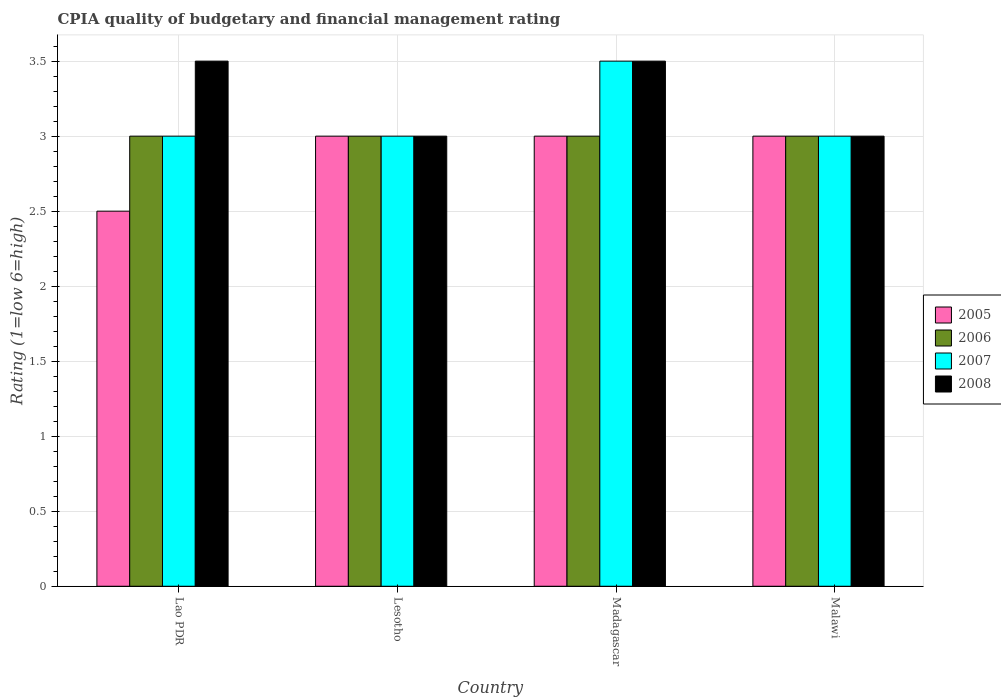How many different coloured bars are there?
Ensure brevity in your answer.  4. How many bars are there on the 2nd tick from the left?
Provide a short and direct response. 4. What is the label of the 1st group of bars from the left?
Provide a succinct answer. Lao PDR. In how many cases, is the number of bars for a given country not equal to the number of legend labels?
Provide a short and direct response. 0. Across all countries, what is the minimum CPIA rating in 2006?
Provide a short and direct response. 3. In which country was the CPIA rating in 2005 maximum?
Your response must be concise. Lesotho. In which country was the CPIA rating in 2005 minimum?
Make the answer very short. Lao PDR. What is the total CPIA rating in 2007 in the graph?
Offer a terse response. 12.5. What is the difference between the CPIA rating in 2005 in Lao PDR and the CPIA rating in 2006 in Lesotho?
Offer a terse response. -0.5. In how many countries, is the CPIA rating in 2007 greater than 3?
Your answer should be very brief. 1. What is the ratio of the CPIA rating in 2008 in Madagascar to that in Malawi?
Make the answer very short. 1.17. What is the difference between the highest and the second highest CPIA rating in 2007?
Offer a very short reply. -0.5. In how many countries, is the CPIA rating in 2005 greater than the average CPIA rating in 2005 taken over all countries?
Your answer should be compact. 3. Is the sum of the CPIA rating in 2005 in Lao PDR and Madagascar greater than the maximum CPIA rating in 2006 across all countries?
Your answer should be compact. Yes. What does the 1st bar from the left in Lao PDR represents?
Your answer should be very brief. 2005. What does the 4th bar from the right in Lesotho represents?
Keep it short and to the point. 2005. Is it the case that in every country, the sum of the CPIA rating in 2006 and CPIA rating in 2007 is greater than the CPIA rating in 2008?
Give a very brief answer. Yes. How many countries are there in the graph?
Your answer should be compact. 4. Are the values on the major ticks of Y-axis written in scientific E-notation?
Ensure brevity in your answer.  No. Does the graph contain any zero values?
Make the answer very short. No. Where does the legend appear in the graph?
Your answer should be very brief. Center right. How are the legend labels stacked?
Make the answer very short. Vertical. What is the title of the graph?
Your response must be concise. CPIA quality of budgetary and financial management rating. Does "1985" appear as one of the legend labels in the graph?
Offer a terse response. No. What is the Rating (1=low 6=high) of 2005 in Lao PDR?
Offer a very short reply. 2.5. What is the Rating (1=low 6=high) in 2006 in Lao PDR?
Your answer should be compact. 3. What is the Rating (1=low 6=high) in 2007 in Lao PDR?
Give a very brief answer. 3. What is the Rating (1=low 6=high) in 2005 in Lesotho?
Offer a very short reply. 3. What is the Rating (1=low 6=high) in 2006 in Lesotho?
Your answer should be compact. 3. What is the Rating (1=low 6=high) of 2008 in Lesotho?
Your response must be concise. 3. What is the Rating (1=low 6=high) in 2005 in Madagascar?
Provide a succinct answer. 3. What is the Rating (1=low 6=high) in 2006 in Madagascar?
Keep it short and to the point. 3. What is the Rating (1=low 6=high) of 2005 in Malawi?
Your response must be concise. 3. What is the Rating (1=low 6=high) in 2008 in Malawi?
Your response must be concise. 3. Across all countries, what is the maximum Rating (1=low 6=high) in 2005?
Provide a short and direct response. 3. Across all countries, what is the maximum Rating (1=low 6=high) of 2006?
Provide a succinct answer. 3. Across all countries, what is the maximum Rating (1=low 6=high) in 2007?
Your answer should be compact. 3.5. Across all countries, what is the maximum Rating (1=low 6=high) in 2008?
Provide a succinct answer. 3.5. Across all countries, what is the minimum Rating (1=low 6=high) in 2005?
Offer a very short reply. 2.5. Across all countries, what is the minimum Rating (1=low 6=high) in 2007?
Your answer should be very brief. 3. What is the total Rating (1=low 6=high) in 2005 in the graph?
Ensure brevity in your answer.  11.5. What is the total Rating (1=low 6=high) of 2007 in the graph?
Provide a succinct answer. 12.5. What is the total Rating (1=low 6=high) of 2008 in the graph?
Offer a terse response. 13. What is the difference between the Rating (1=low 6=high) in 2005 in Lao PDR and that in Lesotho?
Give a very brief answer. -0.5. What is the difference between the Rating (1=low 6=high) in 2008 in Lao PDR and that in Lesotho?
Your answer should be very brief. 0.5. What is the difference between the Rating (1=low 6=high) in 2005 in Lao PDR and that in Madagascar?
Ensure brevity in your answer.  -0.5. What is the difference between the Rating (1=low 6=high) of 2006 in Lao PDR and that in Madagascar?
Keep it short and to the point. 0. What is the difference between the Rating (1=low 6=high) of 2006 in Lao PDR and that in Malawi?
Provide a succinct answer. 0. What is the difference between the Rating (1=low 6=high) in 2007 in Lao PDR and that in Malawi?
Your answer should be compact. 0. What is the difference between the Rating (1=low 6=high) in 2006 in Lesotho and that in Madagascar?
Make the answer very short. 0. What is the difference between the Rating (1=low 6=high) in 2007 in Lesotho and that in Madagascar?
Keep it short and to the point. -0.5. What is the difference between the Rating (1=low 6=high) in 2008 in Lesotho and that in Madagascar?
Your answer should be very brief. -0.5. What is the difference between the Rating (1=low 6=high) of 2005 in Lesotho and that in Malawi?
Provide a succinct answer. 0. What is the difference between the Rating (1=low 6=high) in 2006 in Lesotho and that in Malawi?
Your response must be concise. 0. What is the difference between the Rating (1=low 6=high) in 2007 in Lesotho and that in Malawi?
Offer a very short reply. 0. What is the difference between the Rating (1=low 6=high) of 2005 in Madagascar and that in Malawi?
Provide a short and direct response. 0. What is the difference between the Rating (1=low 6=high) in 2005 in Lao PDR and the Rating (1=low 6=high) in 2007 in Lesotho?
Offer a very short reply. -0.5. What is the difference between the Rating (1=low 6=high) of 2006 in Lao PDR and the Rating (1=low 6=high) of 2008 in Lesotho?
Your response must be concise. 0. What is the difference between the Rating (1=low 6=high) of 2007 in Lao PDR and the Rating (1=low 6=high) of 2008 in Lesotho?
Ensure brevity in your answer.  0. What is the difference between the Rating (1=low 6=high) in 2005 in Lao PDR and the Rating (1=low 6=high) in 2007 in Madagascar?
Keep it short and to the point. -1. What is the difference between the Rating (1=low 6=high) of 2007 in Lao PDR and the Rating (1=low 6=high) of 2008 in Madagascar?
Keep it short and to the point. -0.5. What is the difference between the Rating (1=low 6=high) of 2005 in Lao PDR and the Rating (1=low 6=high) of 2007 in Malawi?
Offer a very short reply. -0.5. What is the difference between the Rating (1=low 6=high) in 2006 in Lao PDR and the Rating (1=low 6=high) in 2007 in Malawi?
Your answer should be compact. 0. What is the difference between the Rating (1=low 6=high) of 2007 in Lao PDR and the Rating (1=low 6=high) of 2008 in Malawi?
Offer a very short reply. 0. What is the difference between the Rating (1=low 6=high) of 2005 in Lesotho and the Rating (1=low 6=high) of 2007 in Madagascar?
Provide a short and direct response. -0.5. What is the difference between the Rating (1=low 6=high) of 2006 in Lesotho and the Rating (1=low 6=high) of 2007 in Madagascar?
Your answer should be compact. -0.5. What is the difference between the Rating (1=low 6=high) in 2006 in Lesotho and the Rating (1=low 6=high) in 2008 in Madagascar?
Give a very brief answer. -0.5. What is the difference between the Rating (1=low 6=high) in 2007 in Lesotho and the Rating (1=low 6=high) in 2008 in Madagascar?
Keep it short and to the point. -0.5. What is the difference between the Rating (1=low 6=high) in 2005 in Lesotho and the Rating (1=low 6=high) in 2006 in Malawi?
Keep it short and to the point. 0. What is the difference between the Rating (1=low 6=high) of 2005 in Lesotho and the Rating (1=low 6=high) of 2007 in Malawi?
Offer a terse response. 0. What is the difference between the Rating (1=low 6=high) of 2005 in Lesotho and the Rating (1=low 6=high) of 2008 in Malawi?
Your answer should be very brief. 0. What is the difference between the Rating (1=low 6=high) in 2006 in Lesotho and the Rating (1=low 6=high) in 2008 in Malawi?
Your answer should be very brief. 0. What is the difference between the Rating (1=low 6=high) in 2005 in Madagascar and the Rating (1=low 6=high) in 2008 in Malawi?
Give a very brief answer. 0. What is the difference between the Rating (1=low 6=high) of 2006 in Madagascar and the Rating (1=low 6=high) of 2008 in Malawi?
Provide a succinct answer. 0. What is the average Rating (1=low 6=high) in 2005 per country?
Your answer should be compact. 2.88. What is the average Rating (1=low 6=high) of 2007 per country?
Your response must be concise. 3.12. What is the difference between the Rating (1=low 6=high) in 2006 and Rating (1=low 6=high) in 2007 in Lao PDR?
Give a very brief answer. 0. What is the difference between the Rating (1=low 6=high) of 2007 and Rating (1=low 6=high) of 2008 in Lao PDR?
Keep it short and to the point. -0.5. What is the difference between the Rating (1=low 6=high) in 2005 and Rating (1=low 6=high) in 2006 in Lesotho?
Offer a very short reply. 0. What is the difference between the Rating (1=low 6=high) of 2005 and Rating (1=low 6=high) of 2007 in Lesotho?
Ensure brevity in your answer.  0. What is the difference between the Rating (1=low 6=high) in 2005 and Rating (1=low 6=high) in 2008 in Lesotho?
Ensure brevity in your answer.  0. What is the difference between the Rating (1=low 6=high) of 2007 and Rating (1=low 6=high) of 2008 in Lesotho?
Make the answer very short. 0. What is the difference between the Rating (1=low 6=high) in 2005 and Rating (1=low 6=high) in 2007 in Madagascar?
Make the answer very short. -0.5. What is the difference between the Rating (1=low 6=high) in 2005 and Rating (1=low 6=high) in 2008 in Madagascar?
Provide a succinct answer. -0.5. What is the difference between the Rating (1=low 6=high) of 2005 and Rating (1=low 6=high) of 2007 in Malawi?
Provide a short and direct response. 0. What is the difference between the Rating (1=low 6=high) of 2005 and Rating (1=low 6=high) of 2008 in Malawi?
Keep it short and to the point. 0. What is the difference between the Rating (1=low 6=high) of 2006 and Rating (1=low 6=high) of 2007 in Malawi?
Offer a terse response. 0. What is the ratio of the Rating (1=low 6=high) of 2005 in Lao PDR to that in Lesotho?
Offer a very short reply. 0.83. What is the ratio of the Rating (1=low 6=high) of 2006 in Lao PDR to that in Lesotho?
Keep it short and to the point. 1. What is the ratio of the Rating (1=low 6=high) of 2007 in Lao PDR to that in Lesotho?
Give a very brief answer. 1. What is the ratio of the Rating (1=low 6=high) of 2008 in Lao PDR to that in Lesotho?
Provide a succinct answer. 1.17. What is the ratio of the Rating (1=low 6=high) of 2005 in Lao PDR to that in Madagascar?
Provide a succinct answer. 0.83. What is the ratio of the Rating (1=low 6=high) in 2007 in Lao PDR to that in Madagascar?
Provide a short and direct response. 0.86. What is the ratio of the Rating (1=low 6=high) of 2006 in Lao PDR to that in Malawi?
Provide a succinct answer. 1. What is the ratio of the Rating (1=low 6=high) of 2008 in Lao PDR to that in Malawi?
Provide a succinct answer. 1.17. What is the ratio of the Rating (1=low 6=high) of 2006 in Lesotho to that in Madagascar?
Keep it short and to the point. 1. What is the ratio of the Rating (1=low 6=high) in 2008 in Lesotho to that in Madagascar?
Make the answer very short. 0.86. What is the ratio of the Rating (1=low 6=high) of 2006 in Lesotho to that in Malawi?
Make the answer very short. 1. What is the ratio of the Rating (1=low 6=high) in 2008 in Lesotho to that in Malawi?
Your answer should be compact. 1. What is the ratio of the Rating (1=low 6=high) of 2005 in Madagascar to that in Malawi?
Provide a succinct answer. 1. What is the ratio of the Rating (1=low 6=high) in 2007 in Madagascar to that in Malawi?
Offer a terse response. 1.17. What is the difference between the highest and the lowest Rating (1=low 6=high) of 2006?
Offer a very short reply. 0. What is the difference between the highest and the lowest Rating (1=low 6=high) in 2008?
Provide a short and direct response. 0.5. 